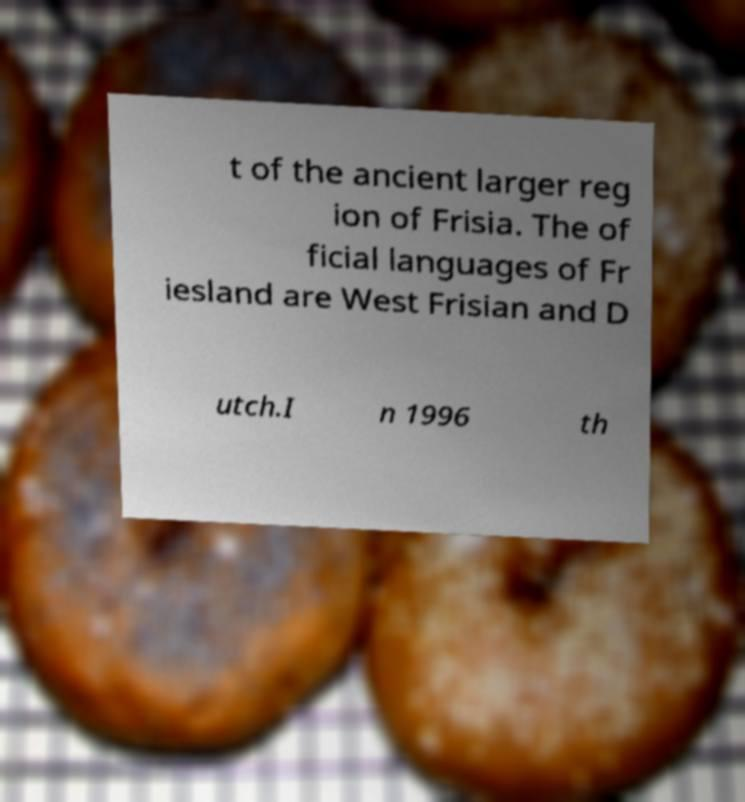I need the written content from this picture converted into text. Can you do that? t of the ancient larger reg ion of Frisia. The of ficial languages of Fr iesland are West Frisian and D utch.I n 1996 th 